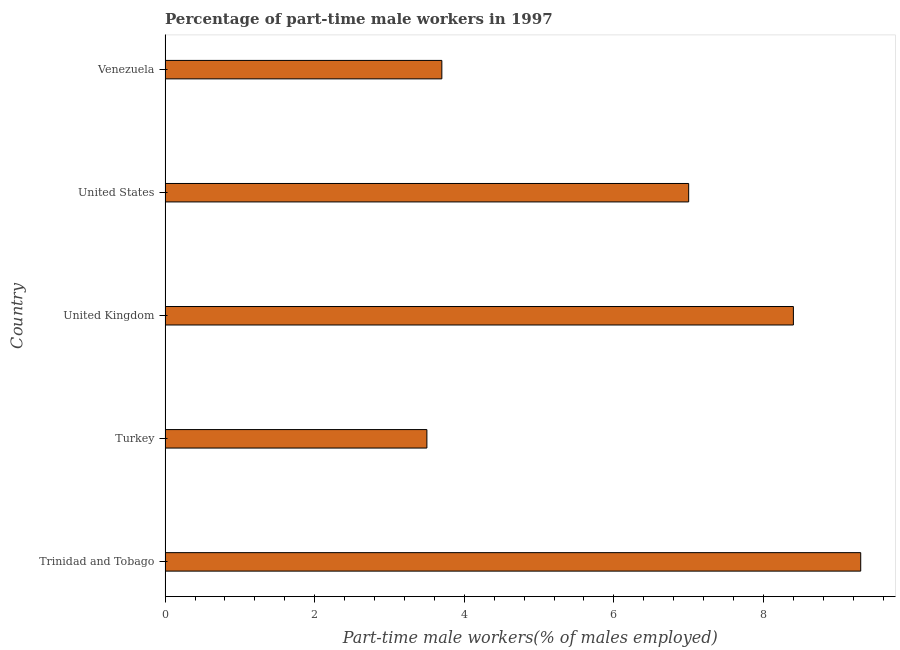Does the graph contain any zero values?
Provide a succinct answer. No. What is the title of the graph?
Your answer should be compact. Percentage of part-time male workers in 1997. What is the label or title of the X-axis?
Your answer should be very brief. Part-time male workers(% of males employed). What is the percentage of part-time male workers in United States?
Keep it short and to the point. 7. Across all countries, what is the maximum percentage of part-time male workers?
Your response must be concise. 9.3. Across all countries, what is the minimum percentage of part-time male workers?
Provide a succinct answer. 3.5. In which country was the percentage of part-time male workers maximum?
Offer a very short reply. Trinidad and Tobago. What is the sum of the percentage of part-time male workers?
Keep it short and to the point. 31.9. What is the difference between the percentage of part-time male workers in Turkey and United States?
Offer a very short reply. -3.5. What is the average percentage of part-time male workers per country?
Offer a very short reply. 6.38. In how many countries, is the percentage of part-time male workers greater than 9.2 %?
Give a very brief answer. 1. What is the ratio of the percentage of part-time male workers in Turkey to that in Venezuela?
Your answer should be compact. 0.95. Is the difference between the percentage of part-time male workers in United States and Venezuela greater than the difference between any two countries?
Your answer should be very brief. No. What is the difference between the highest and the second highest percentage of part-time male workers?
Keep it short and to the point. 0.9. Is the sum of the percentage of part-time male workers in Turkey and Venezuela greater than the maximum percentage of part-time male workers across all countries?
Make the answer very short. No. What is the difference between the highest and the lowest percentage of part-time male workers?
Give a very brief answer. 5.8. In how many countries, is the percentage of part-time male workers greater than the average percentage of part-time male workers taken over all countries?
Provide a succinct answer. 3. How many bars are there?
Provide a succinct answer. 5. How many countries are there in the graph?
Offer a terse response. 5. Are the values on the major ticks of X-axis written in scientific E-notation?
Your answer should be very brief. No. What is the Part-time male workers(% of males employed) of Trinidad and Tobago?
Offer a very short reply. 9.3. What is the Part-time male workers(% of males employed) of United Kingdom?
Give a very brief answer. 8.4. What is the Part-time male workers(% of males employed) of Venezuela?
Your answer should be very brief. 3.7. What is the difference between the Part-time male workers(% of males employed) in Trinidad and Tobago and United Kingdom?
Make the answer very short. 0.9. What is the difference between the Part-time male workers(% of males employed) in Trinidad and Tobago and Venezuela?
Your answer should be compact. 5.6. What is the difference between the Part-time male workers(% of males employed) in Turkey and United Kingdom?
Your answer should be compact. -4.9. What is the difference between the Part-time male workers(% of males employed) in Turkey and United States?
Ensure brevity in your answer.  -3.5. What is the ratio of the Part-time male workers(% of males employed) in Trinidad and Tobago to that in Turkey?
Offer a very short reply. 2.66. What is the ratio of the Part-time male workers(% of males employed) in Trinidad and Tobago to that in United Kingdom?
Ensure brevity in your answer.  1.11. What is the ratio of the Part-time male workers(% of males employed) in Trinidad and Tobago to that in United States?
Your answer should be compact. 1.33. What is the ratio of the Part-time male workers(% of males employed) in Trinidad and Tobago to that in Venezuela?
Your response must be concise. 2.51. What is the ratio of the Part-time male workers(% of males employed) in Turkey to that in United Kingdom?
Provide a short and direct response. 0.42. What is the ratio of the Part-time male workers(% of males employed) in Turkey to that in Venezuela?
Your response must be concise. 0.95. What is the ratio of the Part-time male workers(% of males employed) in United Kingdom to that in Venezuela?
Make the answer very short. 2.27. What is the ratio of the Part-time male workers(% of males employed) in United States to that in Venezuela?
Your answer should be very brief. 1.89. 